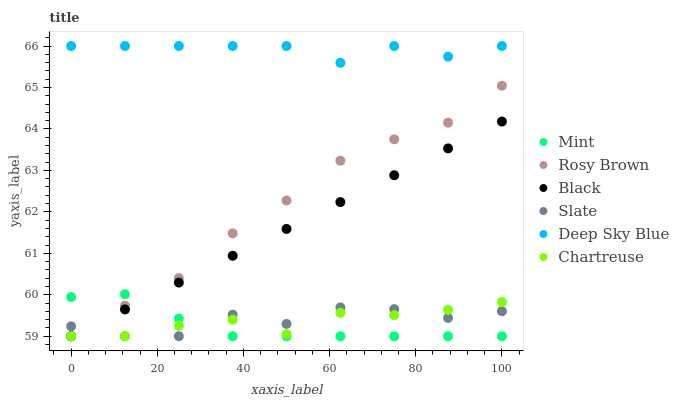Does Mint have the minimum area under the curve?
Answer yes or no. Yes. Does Deep Sky Blue have the maximum area under the curve?
Answer yes or no. Yes. Does Rosy Brown have the minimum area under the curve?
Answer yes or no. No. Does Rosy Brown have the maximum area under the curve?
Answer yes or no. No. Is Black the smoothest?
Answer yes or no. Yes. Is Slate the roughest?
Answer yes or no. Yes. Is Rosy Brown the smoothest?
Answer yes or no. No. Is Rosy Brown the roughest?
Answer yes or no. No. Does Slate have the lowest value?
Answer yes or no. Yes. Does Deep Sky Blue have the lowest value?
Answer yes or no. No. Does Deep Sky Blue have the highest value?
Answer yes or no. Yes. Does Rosy Brown have the highest value?
Answer yes or no. No. Is Rosy Brown less than Deep Sky Blue?
Answer yes or no. Yes. Is Deep Sky Blue greater than Slate?
Answer yes or no. Yes. Does Black intersect Mint?
Answer yes or no. Yes. Is Black less than Mint?
Answer yes or no. No. Is Black greater than Mint?
Answer yes or no. No. Does Rosy Brown intersect Deep Sky Blue?
Answer yes or no. No. 